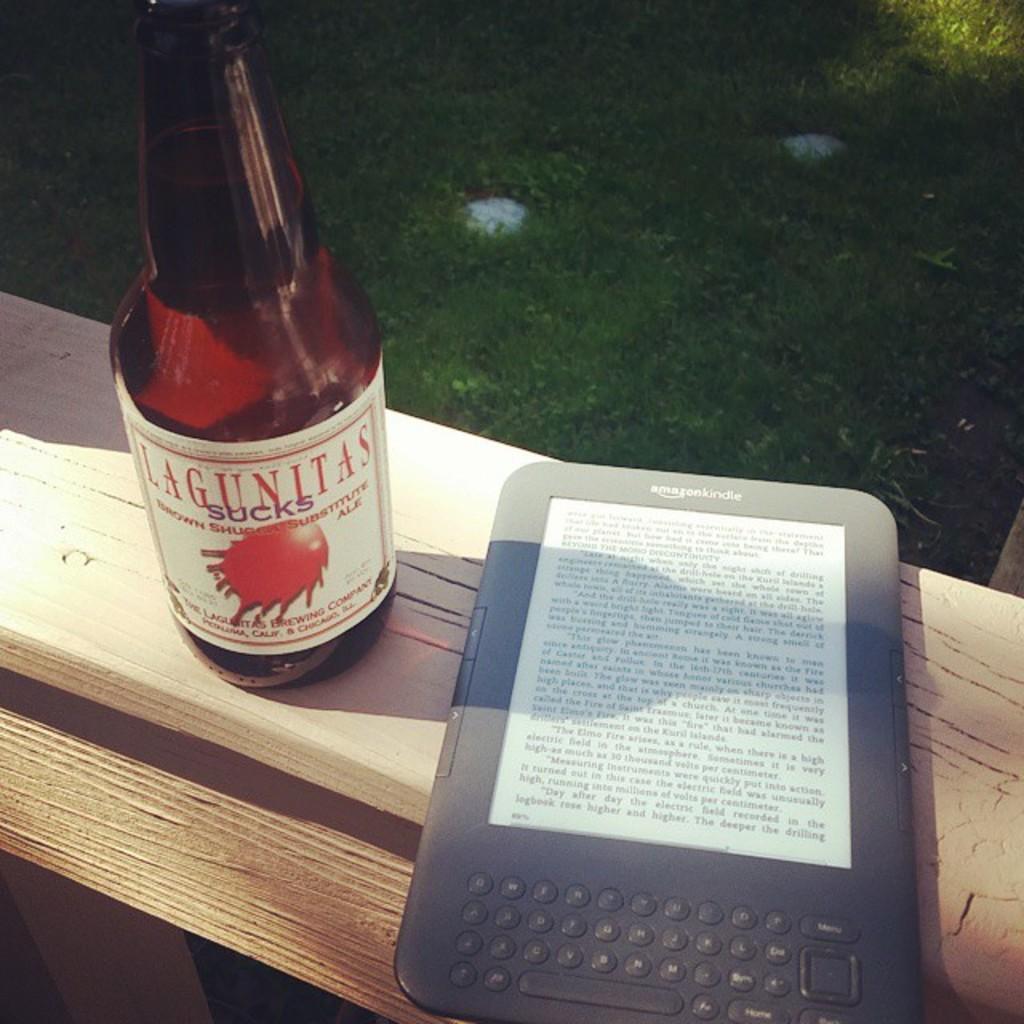How would you summarize this image in a sentence or two? In this image i can see a electronic gadget and a glass with some liquid in it on the bench. In the background i can see the grass. 